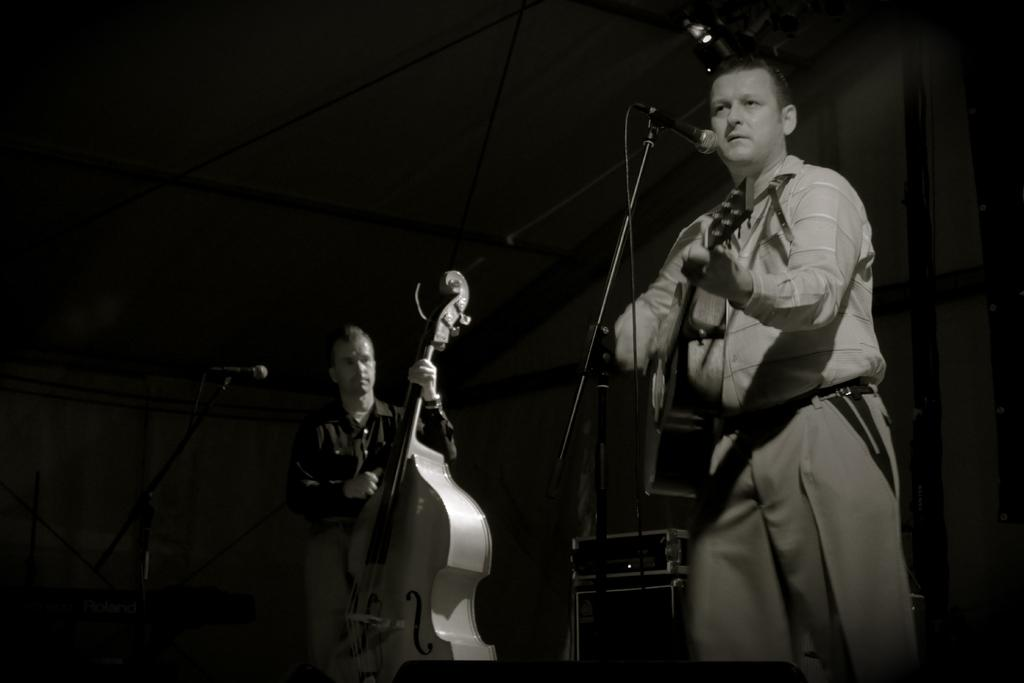How many people are in the image? There are two men in the image. What are the men holding in the image? The men are holding a guitar. Can you describe the position of one of the men? One man is near a microphone. What can be seen in the background of the image? There is a dark wall in the background of the image. How would you describe the lighting in the room? The room appears to be dark. What type of tin can be seen being pulled by the men in the image? There is no tin present in the image, nor are the men pulling anything. 